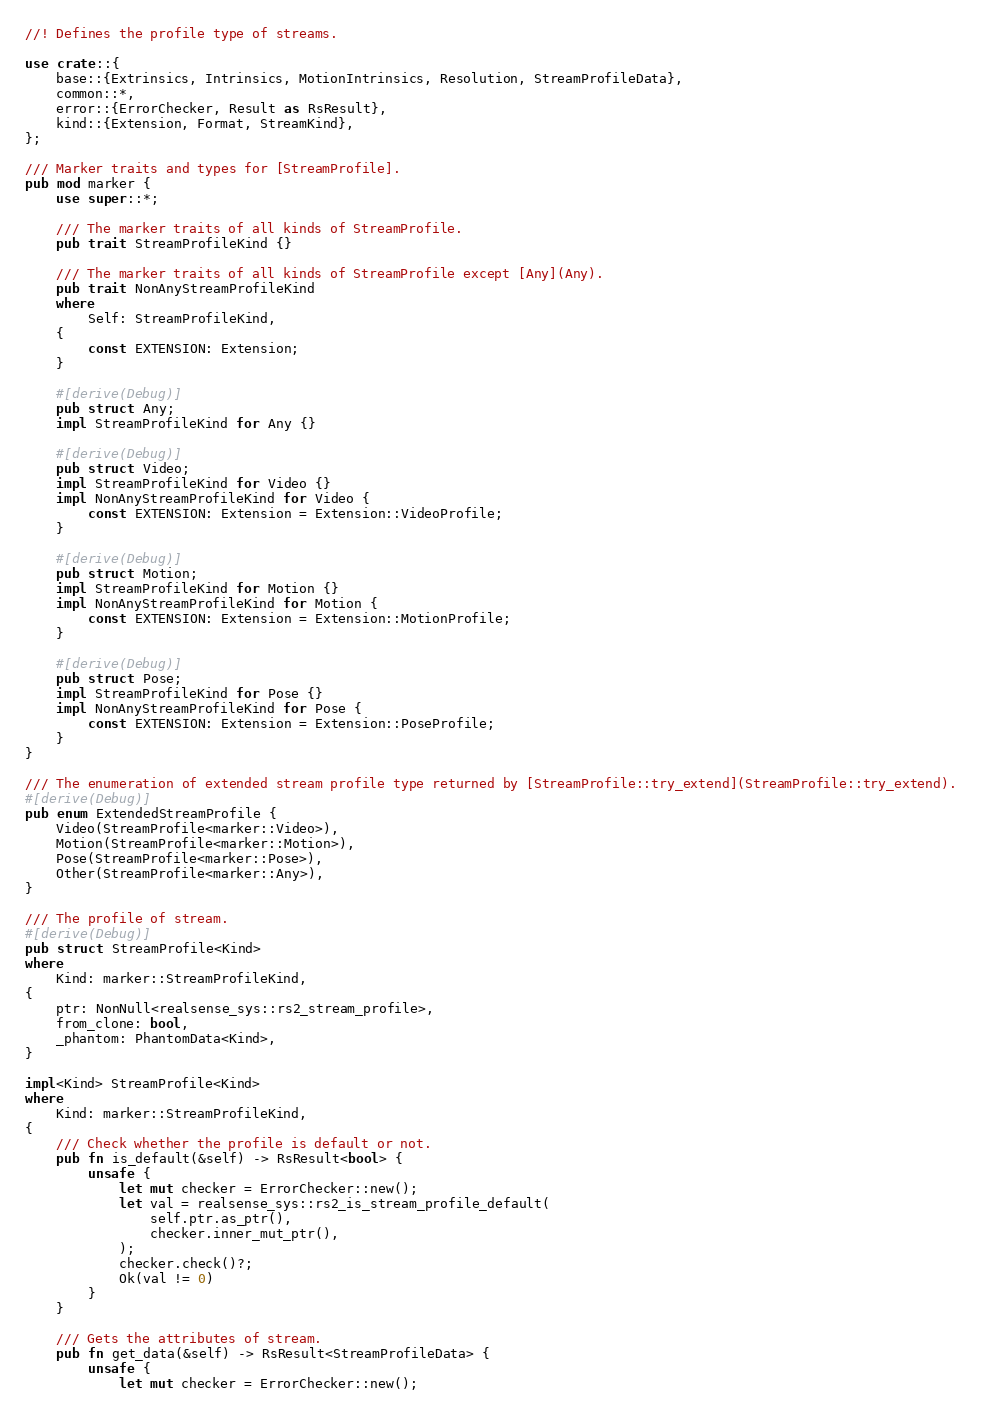<code> <loc_0><loc_0><loc_500><loc_500><_Rust_>//! Defines the profile type of streams.

use crate::{
    base::{Extrinsics, Intrinsics, MotionIntrinsics, Resolution, StreamProfileData},
    common::*,
    error::{ErrorChecker, Result as RsResult},
    kind::{Extension, Format, StreamKind},
};

/// Marker traits and types for [StreamProfile].
pub mod marker {
    use super::*;

    /// The marker traits of all kinds of StreamProfile.
    pub trait StreamProfileKind {}

    /// The marker traits of all kinds of StreamProfile except [Any](Any).
    pub trait NonAnyStreamProfileKind
    where
        Self: StreamProfileKind,
    {
        const EXTENSION: Extension;
    }

    #[derive(Debug)]
    pub struct Any;
    impl StreamProfileKind for Any {}

    #[derive(Debug)]
    pub struct Video;
    impl StreamProfileKind for Video {}
    impl NonAnyStreamProfileKind for Video {
        const EXTENSION: Extension = Extension::VideoProfile;
    }

    #[derive(Debug)]
    pub struct Motion;
    impl StreamProfileKind for Motion {}
    impl NonAnyStreamProfileKind for Motion {
        const EXTENSION: Extension = Extension::MotionProfile;
    }

    #[derive(Debug)]
    pub struct Pose;
    impl StreamProfileKind for Pose {}
    impl NonAnyStreamProfileKind for Pose {
        const EXTENSION: Extension = Extension::PoseProfile;
    }
}

/// The enumeration of extended stream profile type returned by [StreamProfile::try_extend](StreamProfile::try_extend).
#[derive(Debug)]
pub enum ExtendedStreamProfile {
    Video(StreamProfile<marker::Video>),
    Motion(StreamProfile<marker::Motion>),
    Pose(StreamProfile<marker::Pose>),
    Other(StreamProfile<marker::Any>),
}

/// The profile of stream.
#[derive(Debug)]
pub struct StreamProfile<Kind>
where
    Kind: marker::StreamProfileKind,
{
    ptr: NonNull<realsense_sys::rs2_stream_profile>,
    from_clone: bool,
    _phantom: PhantomData<Kind>,
}

impl<Kind> StreamProfile<Kind>
where
    Kind: marker::StreamProfileKind,
{
    /// Check whether the profile is default or not.
    pub fn is_default(&self) -> RsResult<bool> {
        unsafe {
            let mut checker = ErrorChecker::new();
            let val = realsense_sys::rs2_is_stream_profile_default(
                self.ptr.as_ptr(),
                checker.inner_mut_ptr(),
            );
            checker.check()?;
            Ok(val != 0)
        }
    }

    /// Gets the attributes of stream.
    pub fn get_data(&self) -> RsResult<StreamProfileData> {
        unsafe {
            let mut checker = ErrorChecker::new();</code> 